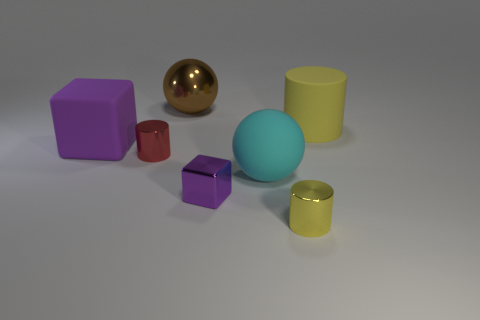There is a cylinder on the left side of the cyan sphere; does it have the same color as the cylinder on the right side of the small yellow cylinder? no 